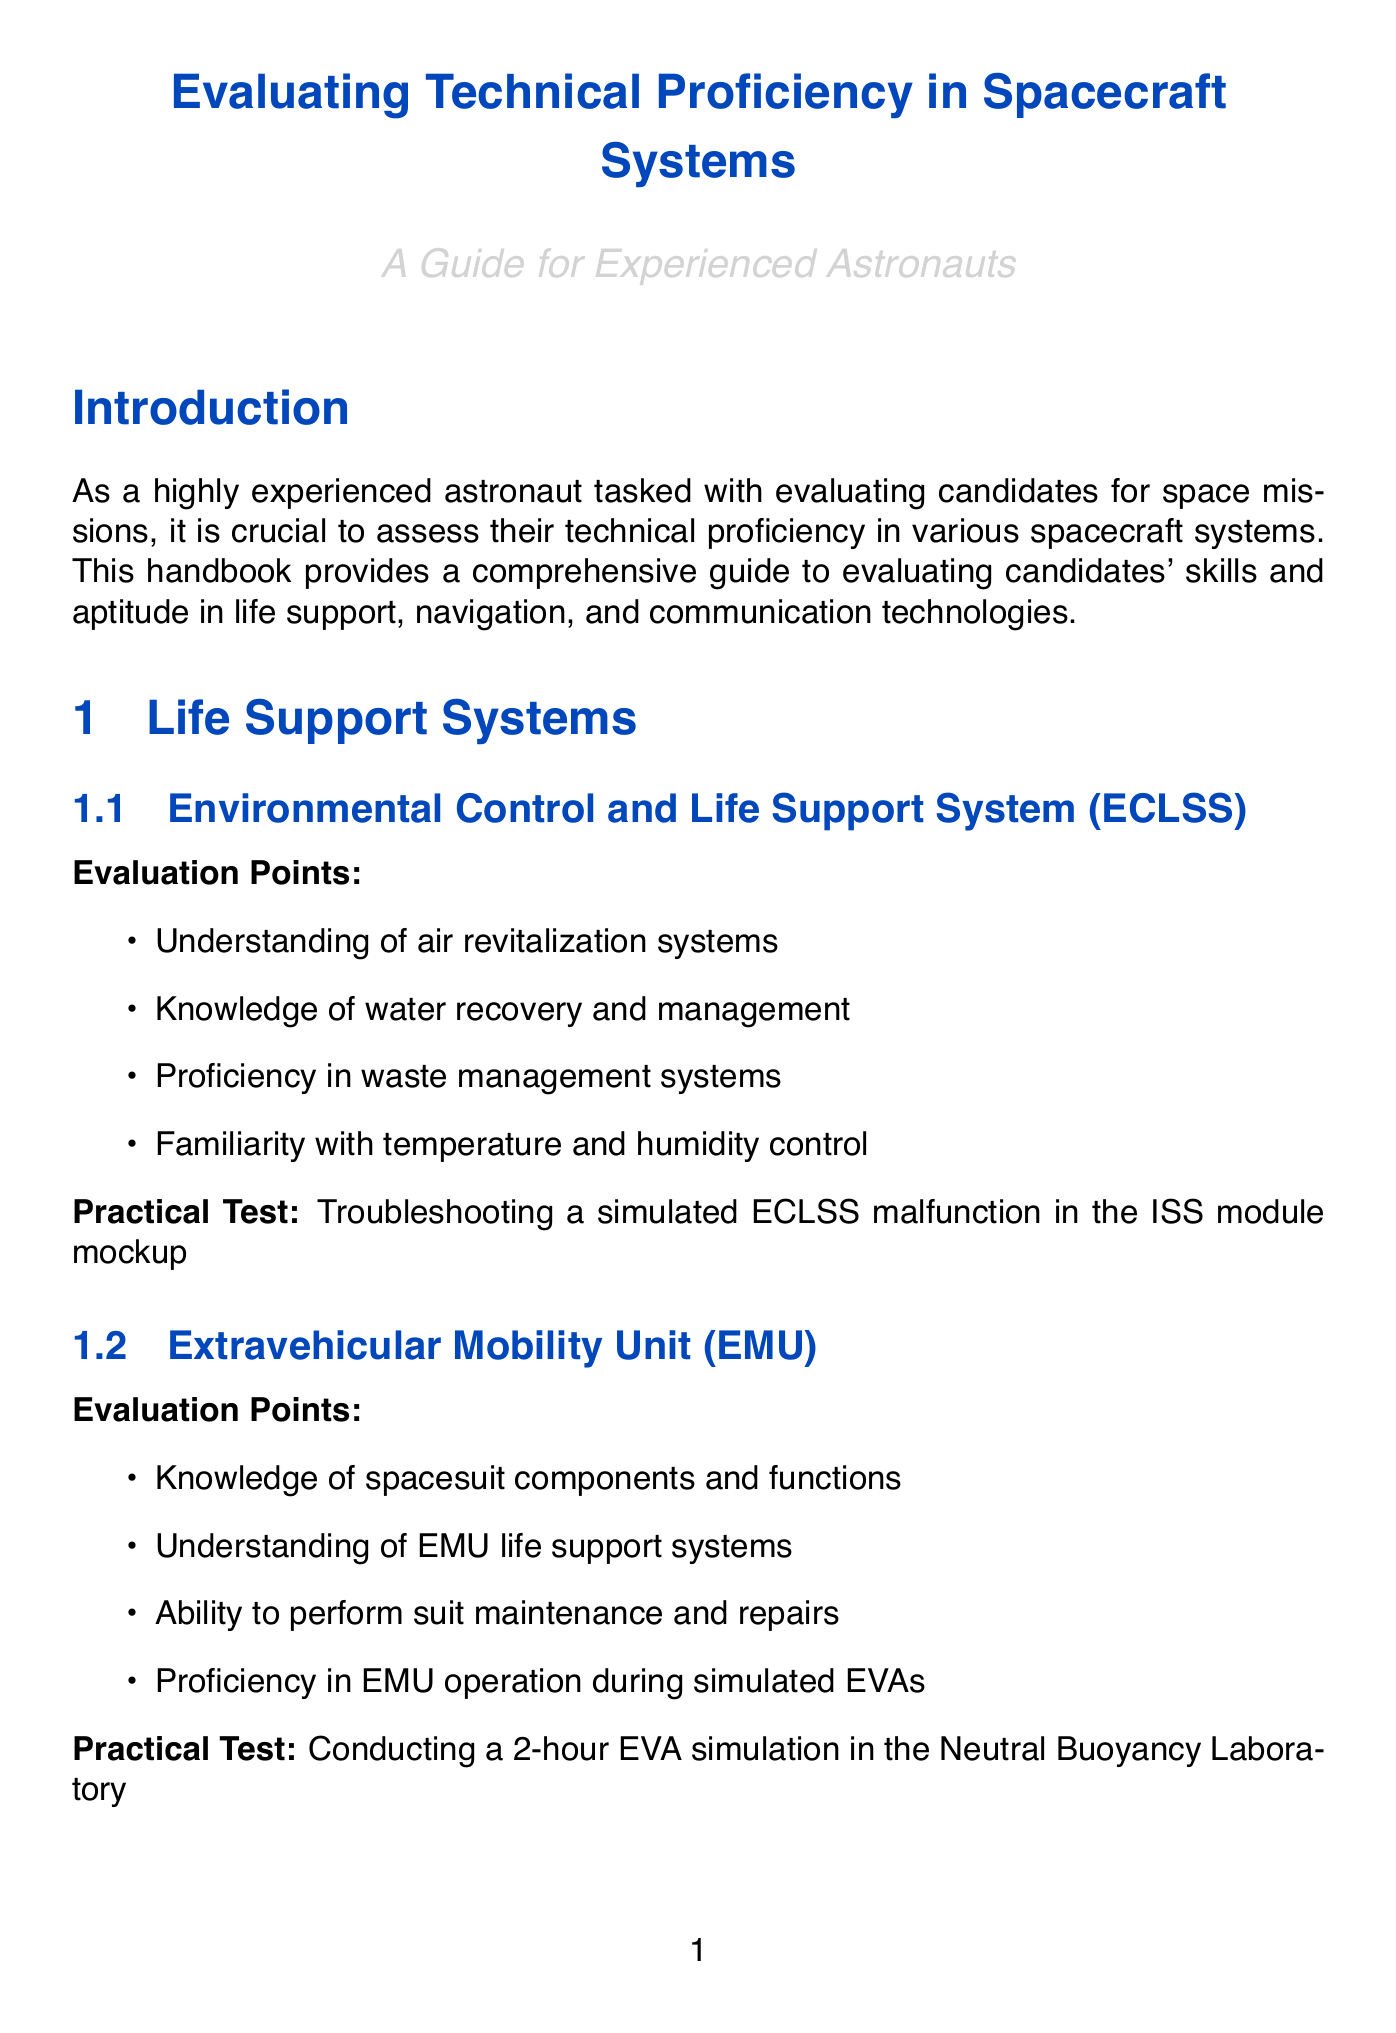What is the title of the handbook? The title is explicitly stated at the beginning of the document, highlighting its purpose.
Answer: Evaluating Technical Proficiency in Spacecraft Systems What is one practical test for the Environmental Control and Life Support System? The practical test is specified under the relevant subsection for ECLSS, demonstrating hands-on evaluation.
Answer: Troubleshooting a simulated ECLSS malfunction in the ISS module mockup How many evaluation points are listed for the Extravehicular Mobility Unit? The number of points is determined by counting the items listed in the subsection.
Answer: Four What is the scoring scale used for major systems? The scoring scale is mentioned in the scoring and ranking section, outlining the evaluation method.
Answer: 100-point scale Which methodology is used to assess cognitive workload? This methodology is mentioned specifically as part of the evaluation methodology section.
Answer: NASA Task Load Index (TLX) What is the practical test associated with the ICU? This test is detailed in the communications technologies section, indicating a specific evaluation scenario.
Answer: Conducting a multi-party conference call between spacecraft, EVA astronauts, and Mission Control using the ICU simulator How many major systems are referenced in the scoring and ranking section? The answer can be found by identifying the systems listed in the corresponding section of the document.
Answer: Three What is required to be assessed during team-based simulation exercises? The document specifies a particular assessment method for team evaluations, addressing collaboration aspects.
Answer: Peer evaluations Which section contains the practical test for using star trackers and gyroscopes? The section is identifiable based on the content related to navigation systems and their subsections.
Answer: Guidance, Navigation, and Control (GNC) 